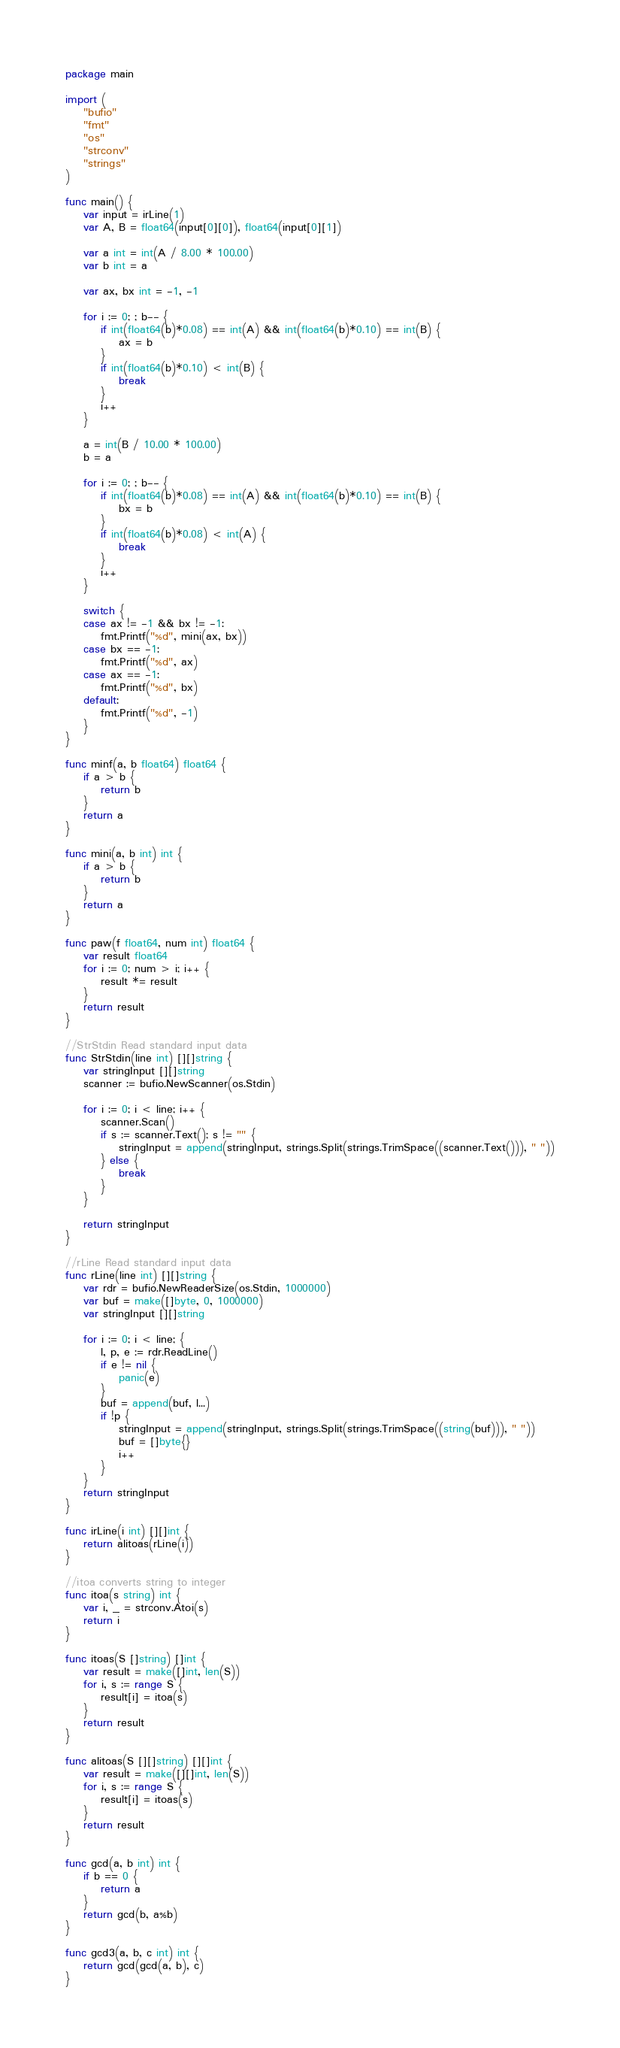<code> <loc_0><loc_0><loc_500><loc_500><_Go_>package main

import (
	"bufio"
	"fmt"
	"os"
	"strconv"
	"strings"
)

func main() {
	var input = irLine(1)
	var A, B = float64(input[0][0]), float64(input[0][1])

	var a int = int(A / 8.00 * 100.00)
	var b int = a

	var ax, bx int = -1, -1

	for i := 0; ; b-- {
		if int(float64(b)*0.08) == int(A) && int(float64(b)*0.10) == int(B) {
			ax = b
		}
		if int(float64(b)*0.10) < int(B) {
			break
		}
		i++
	}

	a = int(B / 10.00 * 100.00)
	b = a

	for i := 0; ; b-- {
		if int(float64(b)*0.08) == int(A) && int(float64(b)*0.10) == int(B) {
			bx = b
		}
		if int(float64(b)*0.08) < int(A) {
			break
		}
		i++
	}

	switch {
	case ax != -1 && bx != -1:
		fmt.Printf("%d", mini(ax, bx))
	case bx == -1:
		fmt.Printf("%d", ax)
	case ax == -1:
		fmt.Printf("%d", bx)
	default:
		fmt.Printf("%d", -1)
	}
}

func minf(a, b float64) float64 {
	if a > b {
		return b
	}
	return a
}

func mini(a, b int) int {
	if a > b {
		return b
	}
	return a
}

func paw(f float64, num int) float64 {
	var result float64
	for i := 0; num > i; i++ {
		result *= result
	}
	return result
}

//StrStdin Read standard input data
func StrStdin(line int) [][]string {
	var stringInput [][]string
	scanner := bufio.NewScanner(os.Stdin)

	for i := 0; i < line; i++ {
		scanner.Scan()
		if s := scanner.Text(); s != "" {
			stringInput = append(stringInput, strings.Split(strings.TrimSpace((scanner.Text())), " "))
		} else {
			break
		}
	}

	return stringInput
}

//rLine Read standard input data
func rLine(line int) [][]string {
	var rdr = bufio.NewReaderSize(os.Stdin, 1000000)
	var buf = make([]byte, 0, 1000000)
	var stringInput [][]string

	for i := 0; i < line; {
		l, p, e := rdr.ReadLine()
		if e != nil {
			panic(e)
		}
		buf = append(buf, l...)
		if !p {
			stringInput = append(stringInput, strings.Split(strings.TrimSpace((string(buf))), " "))
			buf = []byte{}
			i++
		}
	}
	return stringInput
}

func irLine(i int) [][]int {
	return alitoas(rLine(i))
}

//itoa converts string to integer
func itoa(s string) int {
	var i, _ = strconv.Atoi(s)
	return i
}

func itoas(S []string) []int {
	var result = make([]int, len(S))
	for i, s := range S {
		result[i] = itoa(s)
	}
	return result
}

func alitoas(S [][]string) [][]int {
	var result = make([][]int, len(S))
	for i, s := range S {
		result[i] = itoas(s)
	}
	return result
}

func gcd(a, b int) int {
	if b == 0 {
		return a
	}
	return gcd(b, a%b)
}

func gcd3(a, b, c int) int {
	return gcd(gcd(a, b), c)
}
</code> 